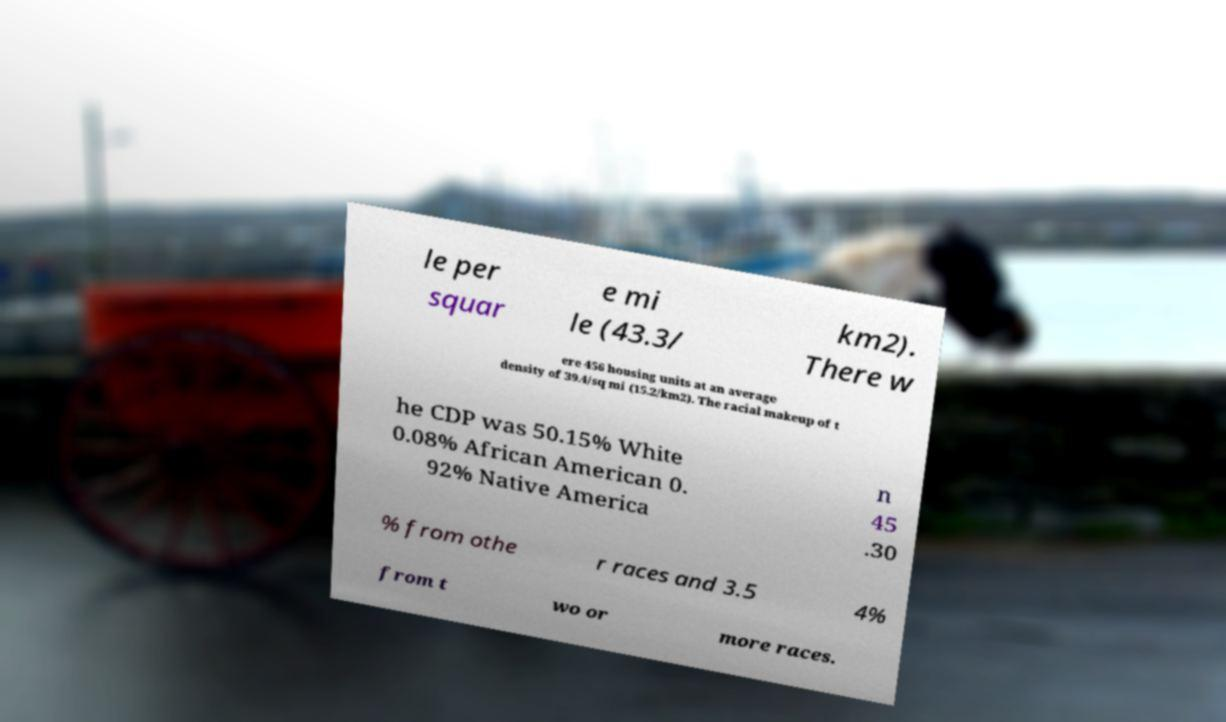Can you accurately transcribe the text from the provided image for me? le per squar e mi le (43.3/ km2). There w ere 456 housing units at an average density of 39.4/sq mi (15.2/km2). The racial makeup of t he CDP was 50.15% White 0.08% African American 0. 92% Native America n 45 .30 % from othe r races and 3.5 4% from t wo or more races. 